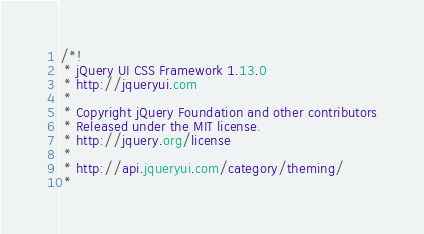Convert code to text. <code><loc_0><loc_0><loc_500><loc_500><_CSS_>/*!
 * jQuery UI CSS Framework 1.13.0
 * http://jqueryui.com
 *
 * Copyright jQuery Foundation and other contributors
 * Released under the MIT license.
 * http://jquery.org/license
 *
 * http://api.jqueryui.com/category/theming/
 *</code> 